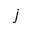Convert formula to latex. <formula><loc_0><loc_0><loc_500><loc_500>j</formula> 